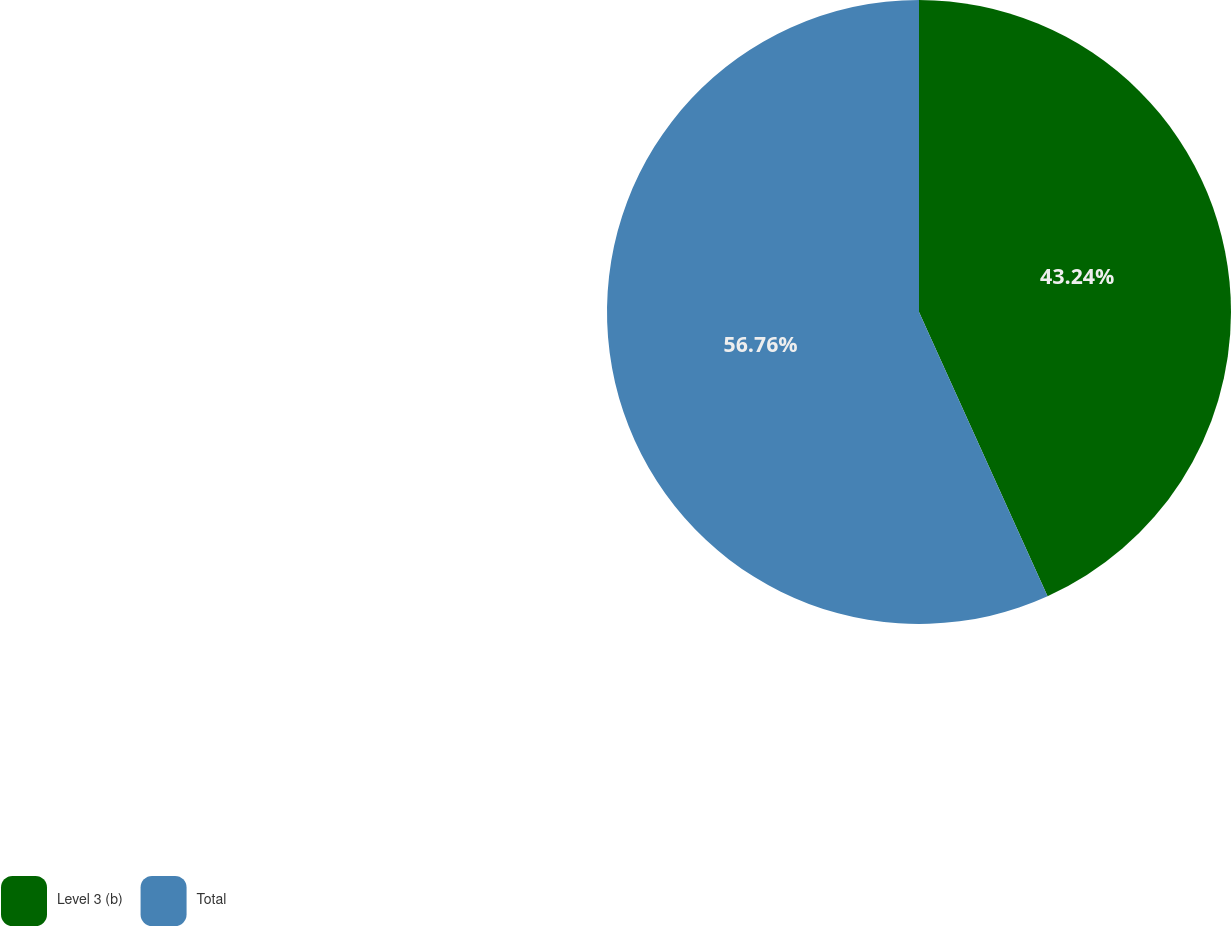Convert chart to OTSL. <chart><loc_0><loc_0><loc_500><loc_500><pie_chart><fcel>Level 3 (b)<fcel>Total<nl><fcel>43.24%<fcel>56.76%<nl></chart> 